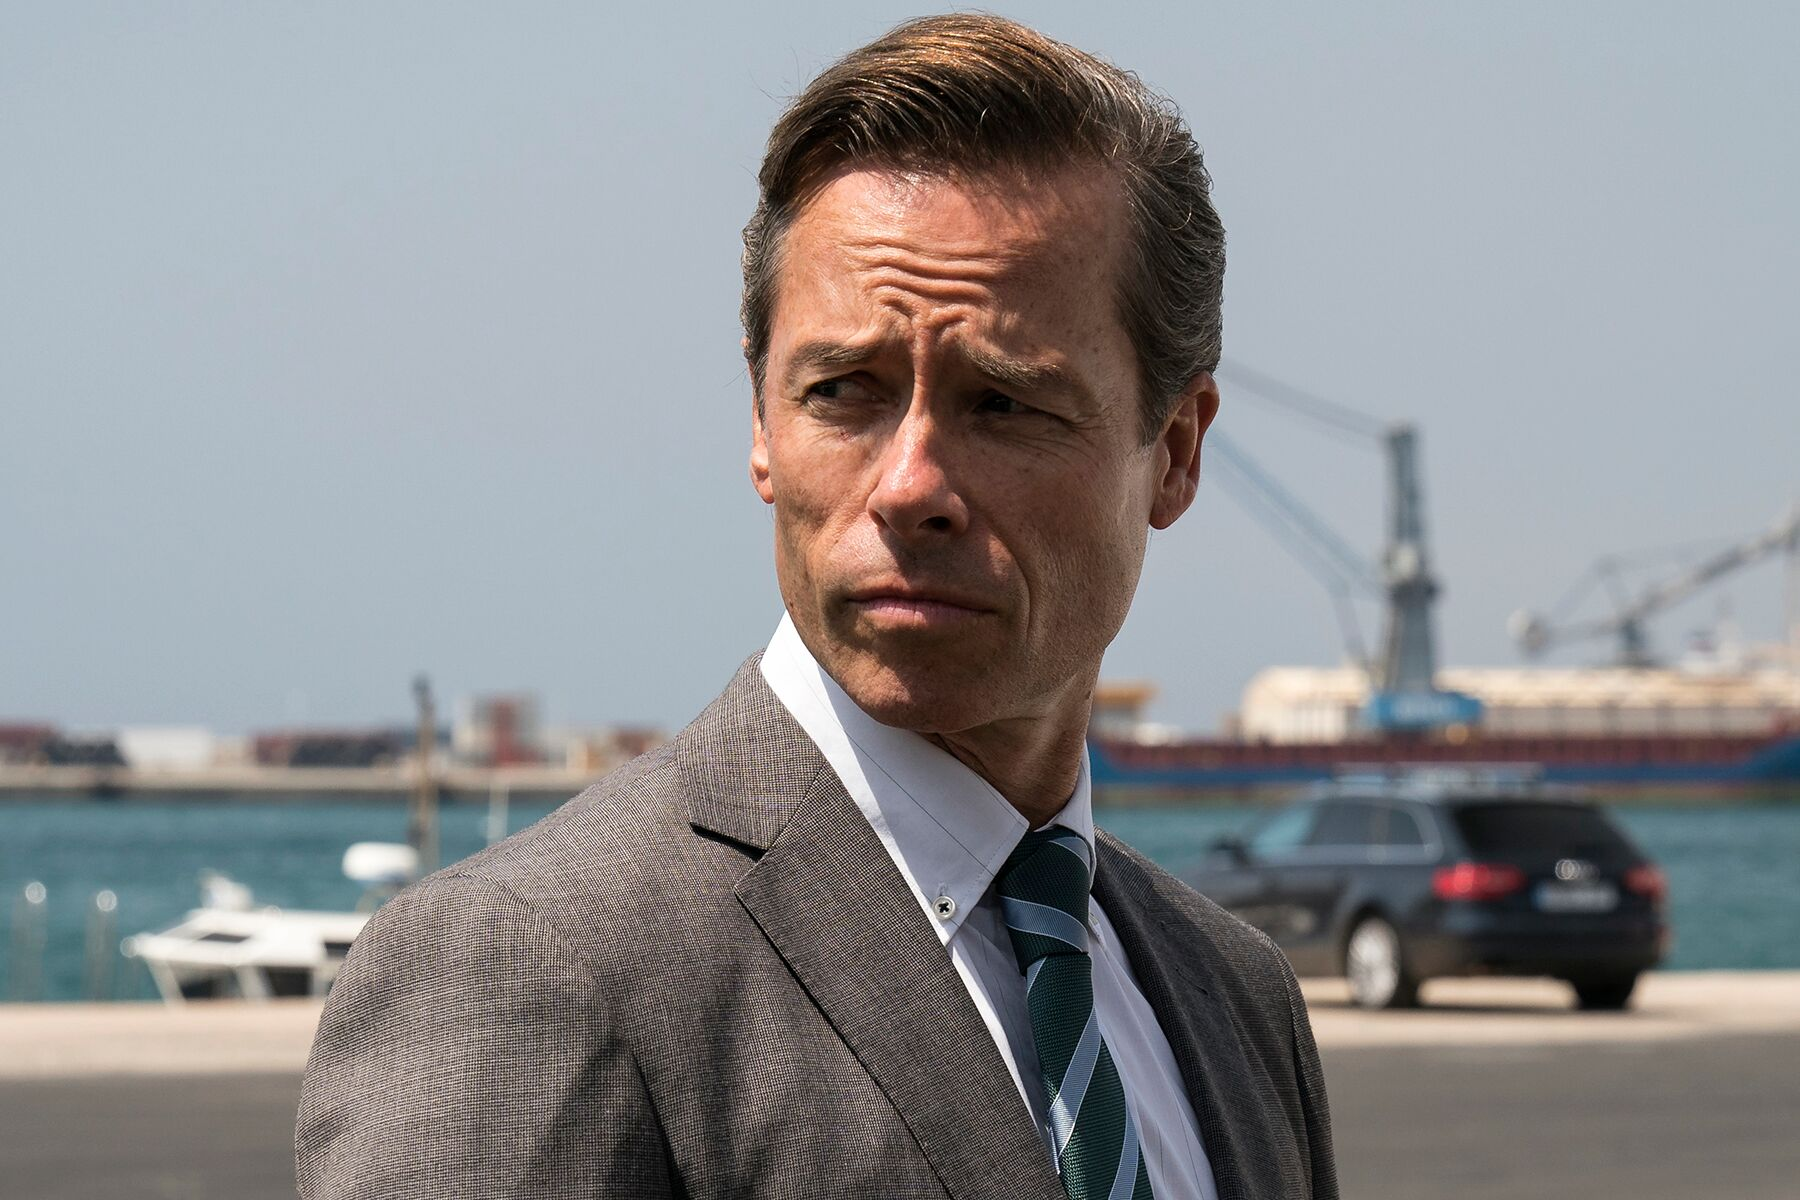Imagine a very unexpected event happening in this scene. Describe it in detail. As the man stands contemplating his thoughts, the serene yet industrious harbor scene is abruptly shattered. A massive sea creature, resembling a technologically augmented Kraken, erupts from the waters behind him. Its metallic tentacles writhe and twist, glinting in the sunlight, creating waves that rock the boats violently. The creature's roar, a blend of mechanical and organic fury, echoes through the air. Panicked workers scatter, the bustling port becomes a scene of chaos. The man, however, does not flinch; his gaze sharpens and he reaches for a device in his pocket, clearly expecting this monstrous event. The atmosphere is thick with tension as he prepares to confront the unimaginable threat, suggesting a twist in the storyline where reality intersects with sci-fi fantastical elements. 